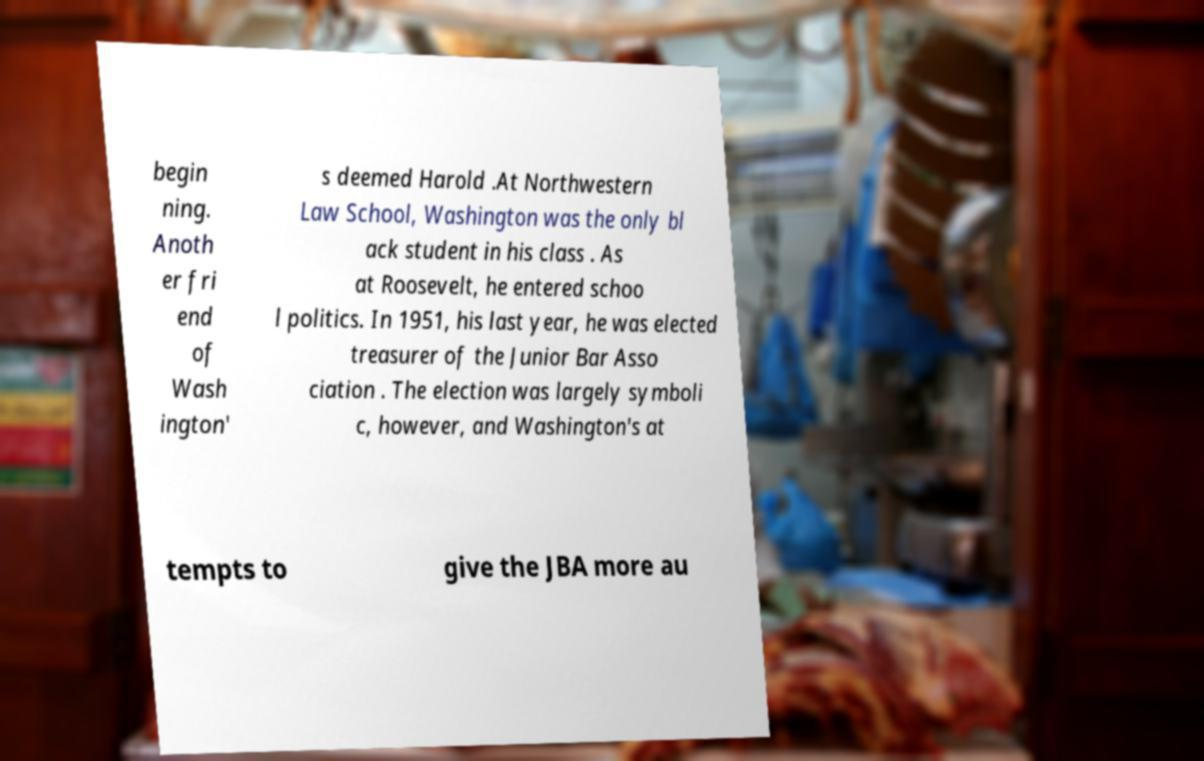Can you read and provide the text displayed in the image?This photo seems to have some interesting text. Can you extract and type it out for me? begin ning. Anoth er fri end of Wash ington' s deemed Harold .At Northwestern Law School, Washington was the only bl ack student in his class . As at Roosevelt, he entered schoo l politics. In 1951, his last year, he was elected treasurer of the Junior Bar Asso ciation . The election was largely symboli c, however, and Washington's at tempts to give the JBA more au 